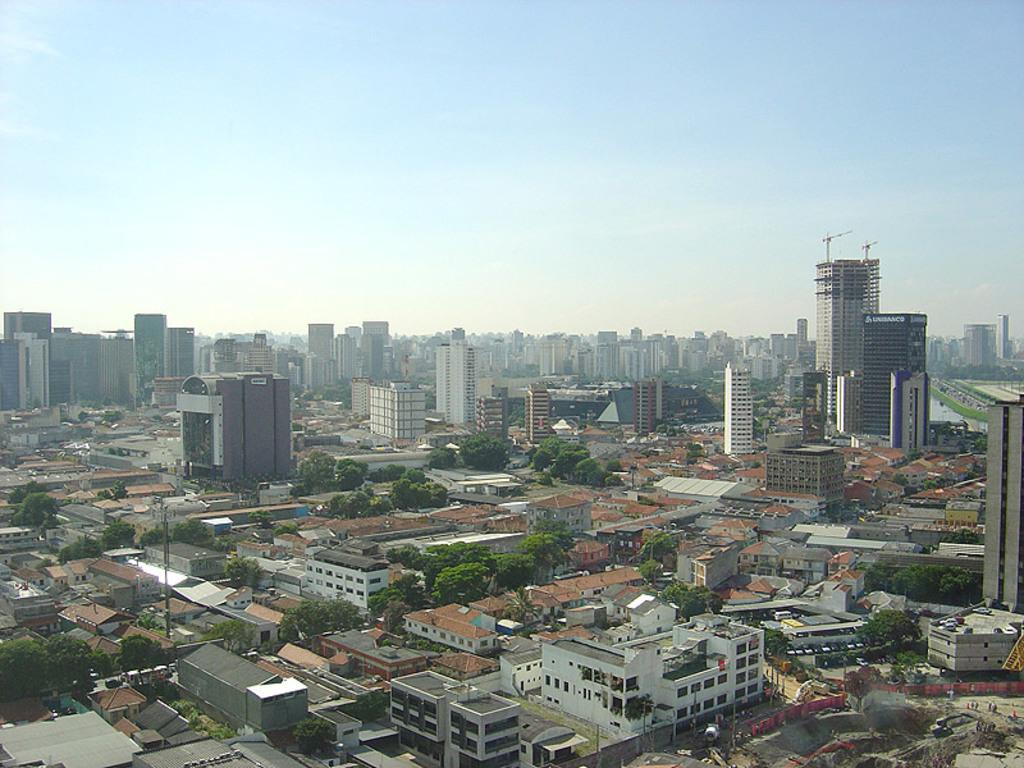What types of structures are visible in the image? There are many buildings in the image. What other elements can be seen in the image besides buildings? There are trees in the image. What can be seen in the background of the image? The sky is visible in the background of the image. What type of collar can be seen on the trees in the image? There are no collars present on the trees in the image, as trees do not wear collars. 